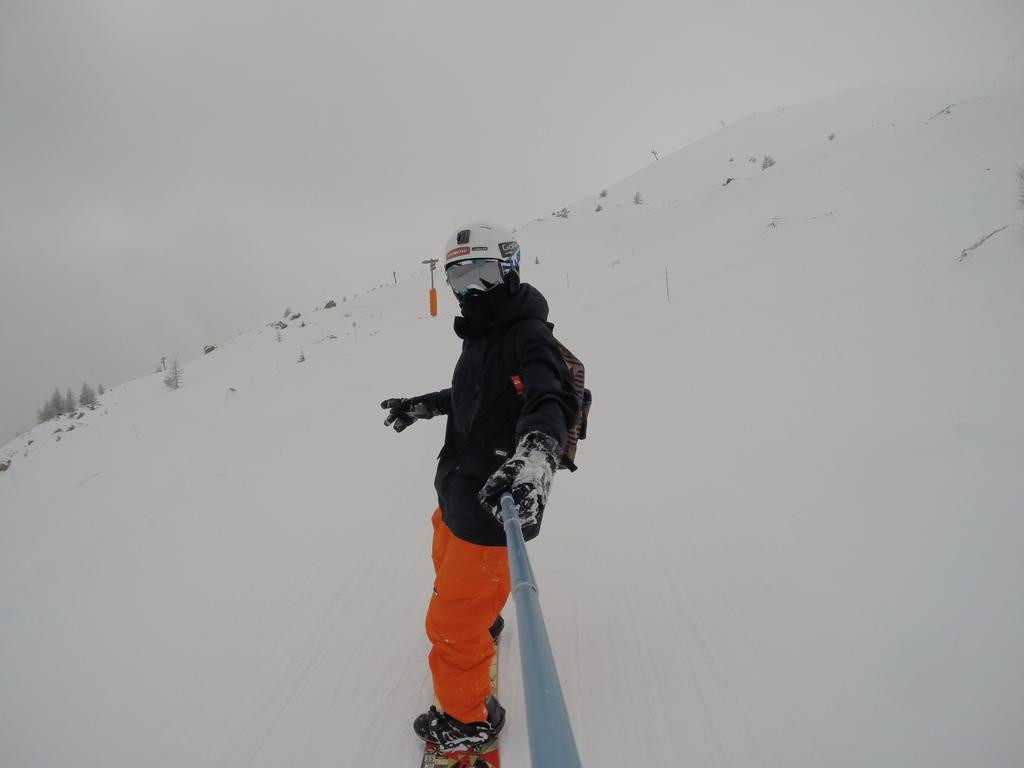What can be seen in the image? There is a person in the image, and the ground is covered with snow. What is the person holding in the image? The person is holding an object. How does the ground appear in the image? The ground is covered with snow. What else can be seen on the snow-covered ground? There are objects on the snow-covered ground. What type of vegetation is visible in the image? There are plants visible in the image. What is visible in the background of the image? The sky is visible in the image. What type of cable can be seen connecting the plants in the image? There is no cable connecting the plants in the image; the plants are not connected by any visible means. 